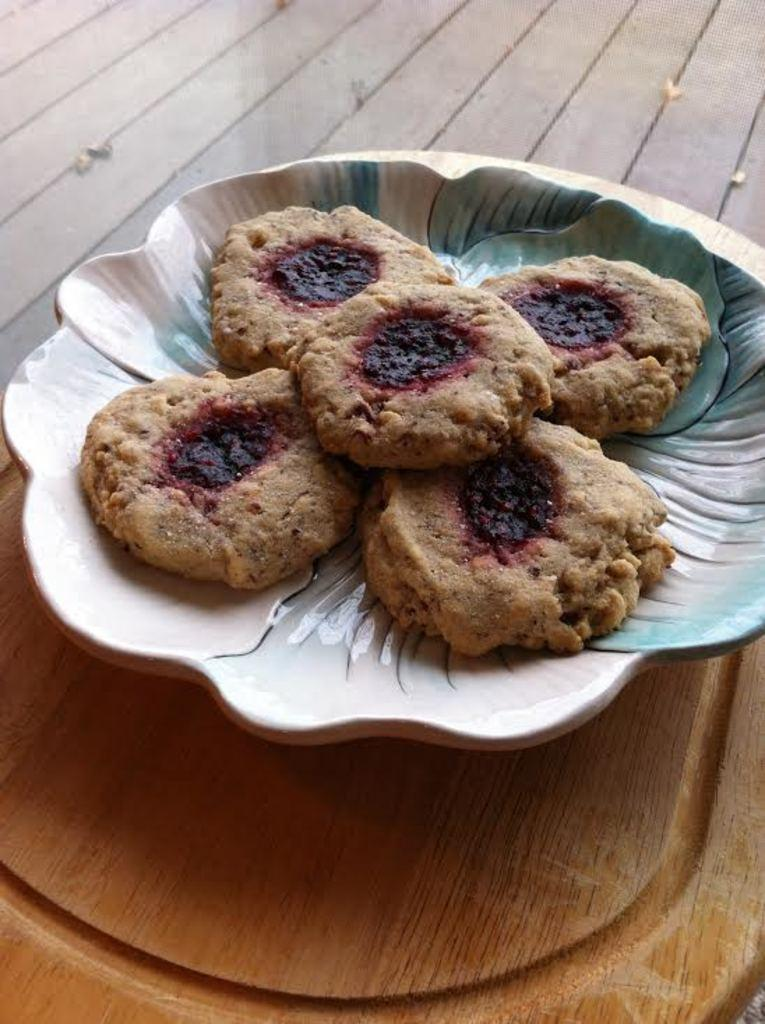What type of furniture is present in the image? There is a table in the image. What is placed on the table? There is a plate on the table. What is on the plate? There are five cookies on the plate. How are the cookies arranged on the plate? The cookies are arranged one beside the other. How much money is on the table in the image? There is no money present in the image; it only features a table, a plate, and five cookies arranged on the plate. 